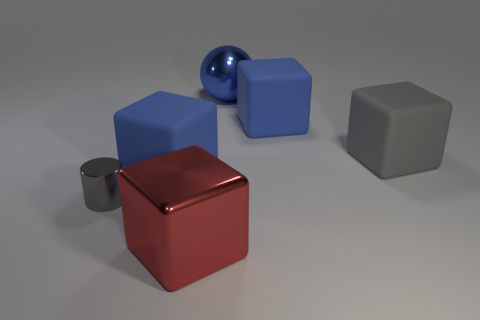Add 3 large yellow rubber cylinders. How many objects exist? 9 Subtract all large metallic cubes. How many cubes are left? 3 Subtract all gray cylinders. How many blue blocks are left? 2 Subtract 1 cubes. How many cubes are left? 3 Subtract all gray blocks. How many blocks are left? 3 Subtract all purple rubber balls. Subtract all gray things. How many objects are left? 4 Add 3 gray metallic cylinders. How many gray metallic cylinders are left? 4 Add 6 blue spheres. How many blue spheres exist? 7 Subtract 1 gray cubes. How many objects are left? 5 Subtract all cubes. How many objects are left? 2 